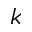<formula> <loc_0><loc_0><loc_500><loc_500>k</formula> 